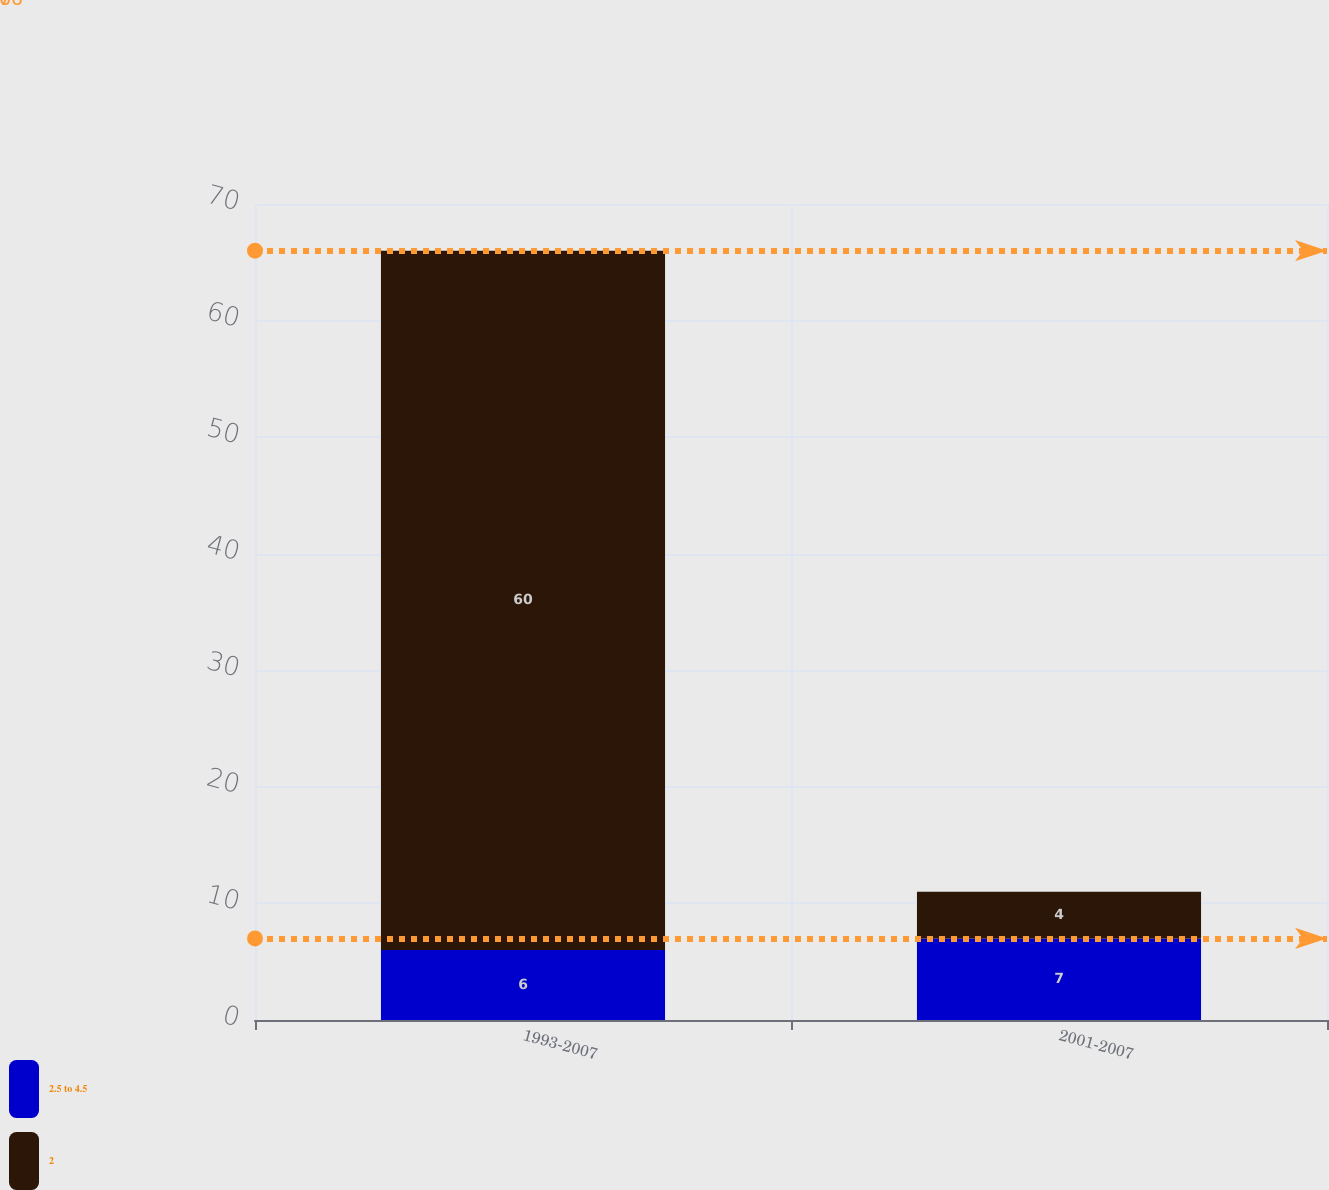<chart> <loc_0><loc_0><loc_500><loc_500><stacked_bar_chart><ecel><fcel>1993-2007<fcel>2001-2007<nl><fcel>2.5 to 4.5<fcel>6<fcel>7<nl><fcel>2<fcel>60<fcel>4<nl></chart> 